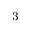<formula> <loc_0><loc_0><loc_500><loc_500>^ { - 3 }</formula> 